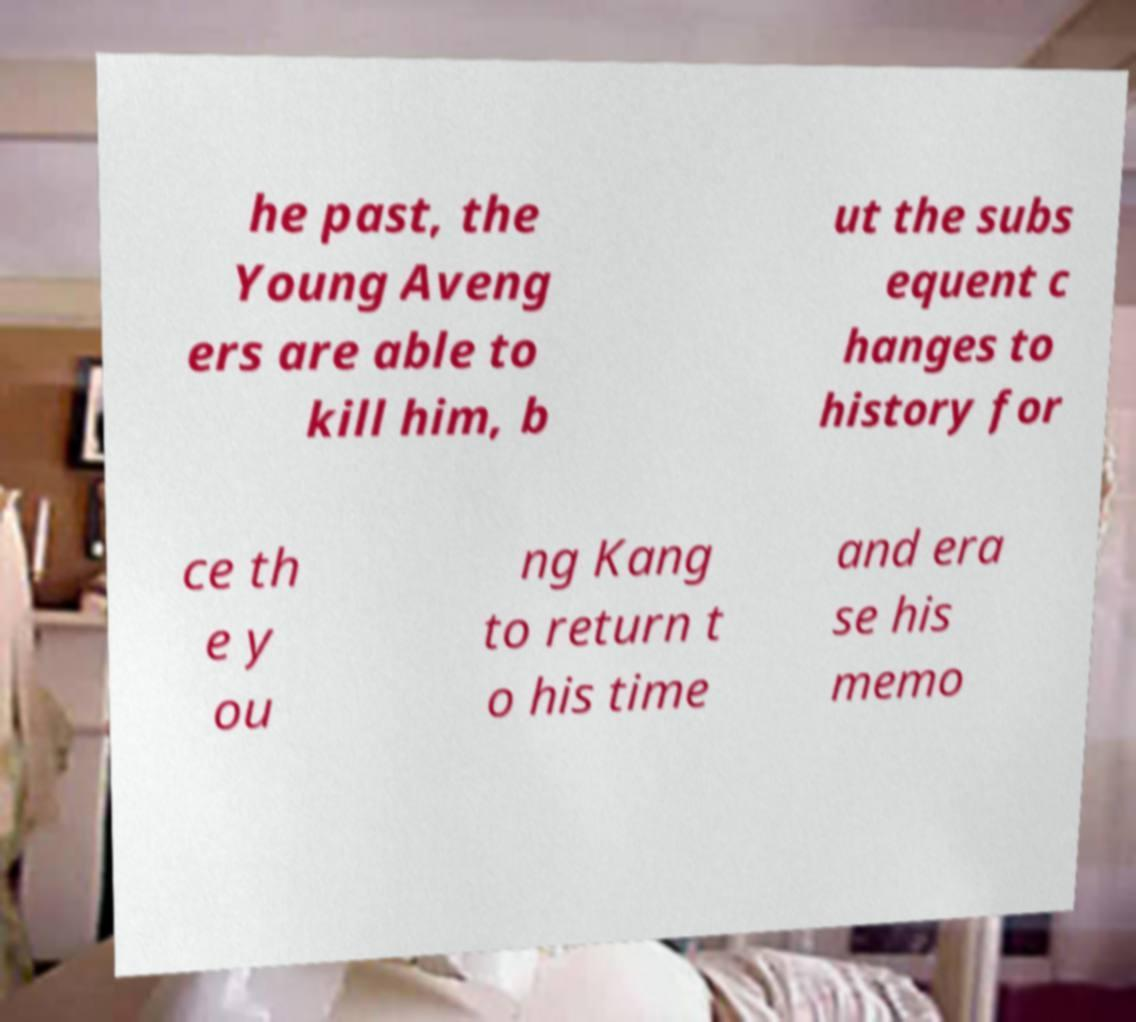Can you read and provide the text displayed in the image?This photo seems to have some interesting text. Can you extract and type it out for me? he past, the Young Aveng ers are able to kill him, b ut the subs equent c hanges to history for ce th e y ou ng Kang to return t o his time and era se his memo 